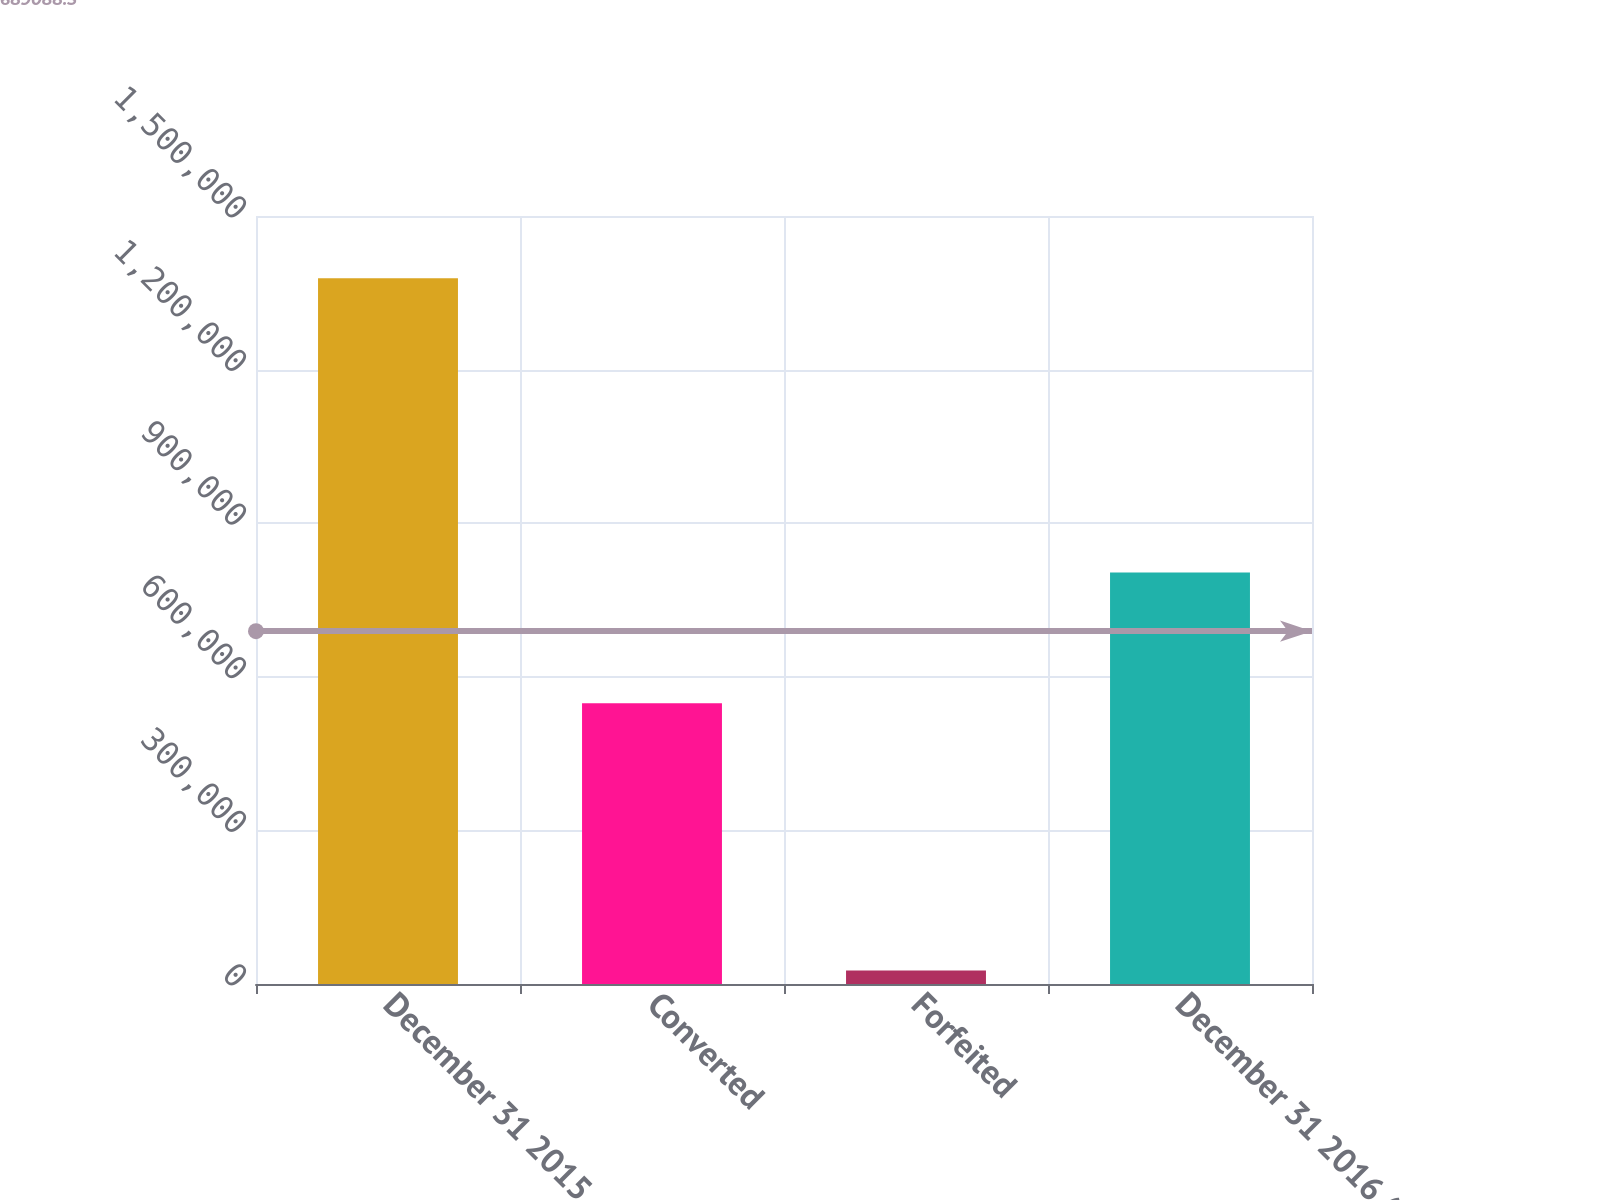<chart> <loc_0><loc_0><loc_500><loc_500><bar_chart><fcel>December 31 2015<fcel>Converted<fcel>Forfeited<fcel>December 31 2016 (1)<nl><fcel>1.37818e+06<fcel>548227<fcel>26476<fcel>803474<nl></chart> 